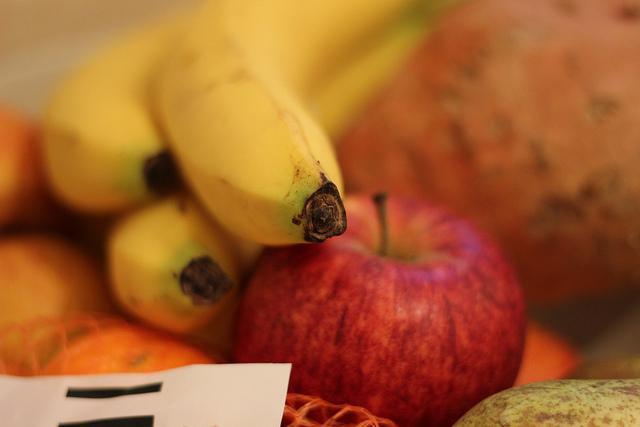How many oranges are there?
Give a very brief answer. 4. How many skateboard wheels can you see?
Give a very brief answer. 0. 